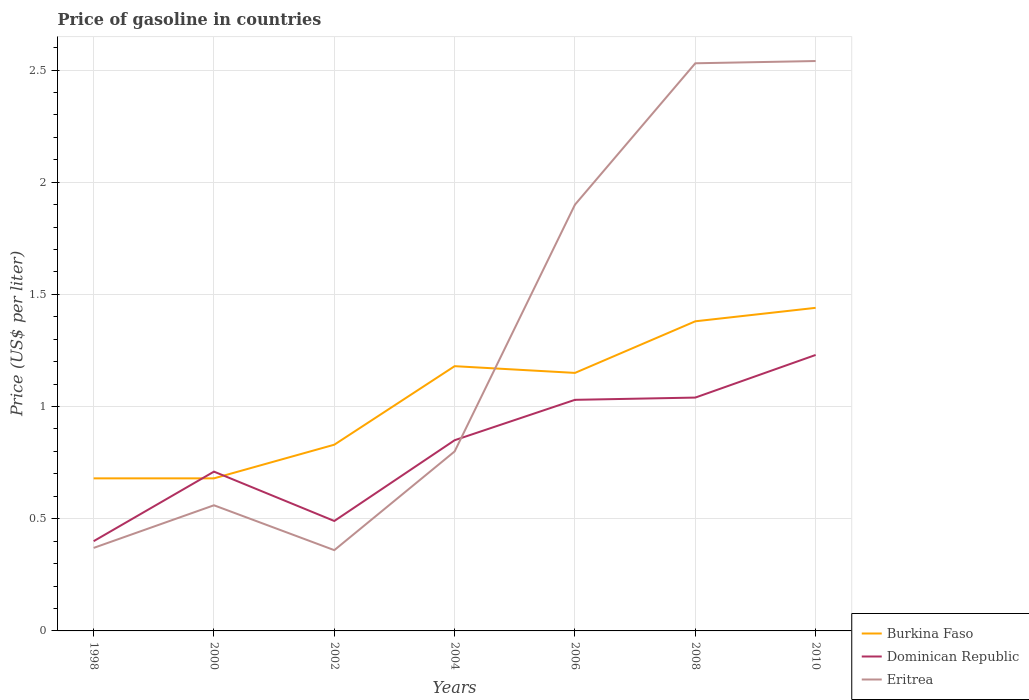How many different coloured lines are there?
Keep it short and to the point. 3. Across all years, what is the maximum price of gasoline in Eritrea?
Provide a short and direct response. 0.36. In which year was the price of gasoline in Burkina Faso maximum?
Offer a terse response. 1998. What is the total price of gasoline in Dominican Republic in the graph?
Keep it short and to the point. -0.32. What is the difference between the highest and the second highest price of gasoline in Eritrea?
Ensure brevity in your answer.  2.18. What is the difference between the highest and the lowest price of gasoline in Burkina Faso?
Give a very brief answer. 4. How many years are there in the graph?
Your answer should be compact. 7. What is the difference between two consecutive major ticks on the Y-axis?
Your response must be concise. 0.5. Are the values on the major ticks of Y-axis written in scientific E-notation?
Give a very brief answer. No. Does the graph contain any zero values?
Keep it short and to the point. No. Where does the legend appear in the graph?
Provide a short and direct response. Bottom right. How are the legend labels stacked?
Your answer should be very brief. Vertical. What is the title of the graph?
Provide a succinct answer. Price of gasoline in countries. Does "South Sudan" appear as one of the legend labels in the graph?
Offer a very short reply. No. What is the label or title of the Y-axis?
Your response must be concise. Price (US$ per liter). What is the Price (US$ per liter) of Burkina Faso in 1998?
Provide a short and direct response. 0.68. What is the Price (US$ per liter) in Dominican Republic in 1998?
Provide a short and direct response. 0.4. What is the Price (US$ per liter) in Eritrea in 1998?
Provide a short and direct response. 0.37. What is the Price (US$ per liter) in Burkina Faso in 2000?
Keep it short and to the point. 0.68. What is the Price (US$ per liter) in Dominican Republic in 2000?
Provide a short and direct response. 0.71. What is the Price (US$ per liter) in Eritrea in 2000?
Offer a very short reply. 0.56. What is the Price (US$ per liter) in Burkina Faso in 2002?
Ensure brevity in your answer.  0.83. What is the Price (US$ per liter) in Dominican Republic in 2002?
Give a very brief answer. 0.49. What is the Price (US$ per liter) of Eritrea in 2002?
Make the answer very short. 0.36. What is the Price (US$ per liter) of Burkina Faso in 2004?
Your response must be concise. 1.18. What is the Price (US$ per liter) of Burkina Faso in 2006?
Offer a terse response. 1.15. What is the Price (US$ per liter) in Dominican Republic in 2006?
Provide a succinct answer. 1.03. What is the Price (US$ per liter) in Burkina Faso in 2008?
Provide a succinct answer. 1.38. What is the Price (US$ per liter) of Dominican Republic in 2008?
Offer a terse response. 1.04. What is the Price (US$ per liter) in Eritrea in 2008?
Provide a succinct answer. 2.53. What is the Price (US$ per liter) in Burkina Faso in 2010?
Provide a succinct answer. 1.44. What is the Price (US$ per liter) in Dominican Republic in 2010?
Keep it short and to the point. 1.23. What is the Price (US$ per liter) in Eritrea in 2010?
Your response must be concise. 2.54. Across all years, what is the maximum Price (US$ per liter) of Burkina Faso?
Provide a succinct answer. 1.44. Across all years, what is the maximum Price (US$ per liter) of Dominican Republic?
Your answer should be very brief. 1.23. Across all years, what is the maximum Price (US$ per liter) in Eritrea?
Provide a short and direct response. 2.54. Across all years, what is the minimum Price (US$ per liter) in Burkina Faso?
Provide a succinct answer. 0.68. Across all years, what is the minimum Price (US$ per liter) in Eritrea?
Make the answer very short. 0.36. What is the total Price (US$ per liter) in Burkina Faso in the graph?
Provide a succinct answer. 7.34. What is the total Price (US$ per liter) of Dominican Republic in the graph?
Offer a very short reply. 5.75. What is the total Price (US$ per liter) of Eritrea in the graph?
Offer a terse response. 9.06. What is the difference between the Price (US$ per liter) of Dominican Republic in 1998 and that in 2000?
Make the answer very short. -0.31. What is the difference between the Price (US$ per liter) of Eritrea in 1998 and that in 2000?
Give a very brief answer. -0.19. What is the difference between the Price (US$ per liter) of Dominican Republic in 1998 and that in 2002?
Offer a terse response. -0.09. What is the difference between the Price (US$ per liter) in Dominican Republic in 1998 and that in 2004?
Make the answer very short. -0.45. What is the difference between the Price (US$ per liter) of Eritrea in 1998 and that in 2004?
Ensure brevity in your answer.  -0.43. What is the difference between the Price (US$ per liter) in Burkina Faso in 1998 and that in 2006?
Your answer should be compact. -0.47. What is the difference between the Price (US$ per liter) of Dominican Republic in 1998 and that in 2006?
Your response must be concise. -0.63. What is the difference between the Price (US$ per liter) in Eritrea in 1998 and that in 2006?
Your answer should be very brief. -1.53. What is the difference between the Price (US$ per liter) in Burkina Faso in 1998 and that in 2008?
Keep it short and to the point. -0.7. What is the difference between the Price (US$ per liter) in Dominican Republic in 1998 and that in 2008?
Keep it short and to the point. -0.64. What is the difference between the Price (US$ per liter) of Eritrea in 1998 and that in 2008?
Offer a very short reply. -2.16. What is the difference between the Price (US$ per liter) of Burkina Faso in 1998 and that in 2010?
Your answer should be compact. -0.76. What is the difference between the Price (US$ per liter) in Dominican Republic in 1998 and that in 2010?
Offer a very short reply. -0.83. What is the difference between the Price (US$ per liter) in Eritrea in 1998 and that in 2010?
Keep it short and to the point. -2.17. What is the difference between the Price (US$ per liter) in Dominican Republic in 2000 and that in 2002?
Your answer should be compact. 0.22. What is the difference between the Price (US$ per liter) in Eritrea in 2000 and that in 2002?
Offer a very short reply. 0.2. What is the difference between the Price (US$ per liter) of Burkina Faso in 2000 and that in 2004?
Your answer should be compact. -0.5. What is the difference between the Price (US$ per liter) of Dominican Republic in 2000 and that in 2004?
Provide a succinct answer. -0.14. What is the difference between the Price (US$ per liter) in Eritrea in 2000 and that in 2004?
Make the answer very short. -0.24. What is the difference between the Price (US$ per liter) of Burkina Faso in 2000 and that in 2006?
Your response must be concise. -0.47. What is the difference between the Price (US$ per liter) of Dominican Republic in 2000 and that in 2006?
Give a very brief answer. -0.32. What is the difference between the Price (US$ per liter) in Eritrea in 2000 and that in 2006?
Ensure brevity in your answer.  -1.34. What is the difference between the Price (US$ per liter) of Burkina Faso in 2000 and that in 2008?
Offer a terse response. -0.7. What is the difference between the Price (US$ per liter) of Dominican Republic in 2000 and that in 2008?
Provide a short and direct response. -0.33. What is the difference between the Price (US$ per liter) of Eritrea in 2000 and that in 2008?
Your answer should be very brief. -1.97. What is the difference between the Price (US$ per liter) of Burkina Faso in 2000 and that in 2010?
Ensure brevity in your answer.  -0.76. What is the difference between the Price (US$ per liter) of Dominican Republic in 2000 and that in 2010?
Make the answer very short. -0.52. What is the difference between the Price (US$ per liter) in Eritrea in 2000 and that in 2010?
Provide a succinct answer. -1.98. What is the difference between the Price (US$ per liter) in Burkina Faso in 2002 and that in 2004?
Give a very brief answer. -0.35. What is the difference between the Price (US$ per liter) in Dominican Republic in 2002 and that in 2004?
Offer a very short reply. -0.36. What is the difference between the Price (US$ per liter) of Eritrea in 2002 and that in 2004?
Your response must be concise. -0.44. What is the difference between the Price (US$ per liter) of Burkina Faso in 2002 and that in 2006?
Give a very brief answer. -0.32. What is the difference between the Price (US$ per liter) in Dominican Republic in 2002 and that in 2006?
Ensure brevity in your answer.  -0.54. What is the difference between the Price (US$ per liter) of Eritrea in 2002 and that in 2006?
Keep it short and to the point. -1.54. What is the difference between the Price (US$ per liter) in Burkina Faso in 2002 and that in 2008?
Ensure brevity in your answer.  -0.55. What is the difference between the Price (US$ per liter) of Dominican Republic in 2002 and that in 2008?
Give a very brief answer. -0.55. What is the difference between the Price (US$ per liter) in Eritrea in 2002 and that in 2008?
Provide a succinct answer. -2.17. What is the difference between the Price (US$ per liter) in Burkina Faso in 2002 and that in 2010?
Keep it short and to the point. -0.61. What is the difference between the Price (US$ per liter) in Dominican Republic in 2002 and that in 2010?
Your answer should be compact. -0.74. What is the difference between the Price (US$ per liter) of Eritrea in 2002 and that in 2010?
Your answer should be very brief. -2.18. What is the difference between the Price (US$ per liter) in Burkina Faso in 2004 and that in 2006?
Provide a succinct answer. 0.03. What is the difference between the Price (US$ per liter) in Dominican Republic in 2004 and that in 2006?
Provide a short and direct response. -0.18. What is the difference between the Price (US$ per liter) in Dominican Republic in 2004 and that in 2008?
Offer a terse response. -0.19. What is the difference between the Price (US$ per liter) of Eritrea in 2004 and that in 2008?
Offer a very short reply. -1.73. What is the difference between the Price (US$ per liter) of Burkina Faso in 2004 and that in 2010?
Make the answer very short. -0.26. What is the difference between the Price (US$ per liter) of Dominican Republic in 2004 and that in 2010?
Provide a short and direct response. -0.38. What is the difference between the Price (US$ per liter) of Eritrea in 2004 and that in 2010?
Offer a terse response. -1.74. What is the difference between the Price (US$ per liter) of Burkina Faso in 2006 and that in 2008?
Your response must be concise. -0.23. What is the difference between the Price (US$ per liter) in Dominican Republic in 2006 and that in 2008?
Your response must be concise. -0.01. What is the difference between the Price (US$ per liter) of Eritrea in 2006 and that in 2008?
Your answer should be compact. -0.63. What is the difference between the Price (US$ per liter) of Burkina Faso in 2006 and that in 2010?
Offer a terse response. -0.29. What is the difference between the Price (US$ per liter) of Eritrea in 2006 and that in 2010?
Ensure brevity in your answer.  -0.64. What is the difference between the Price (US$ per liter) in Burkina Faso in 2008 and that in 2010?
Provide a succinct answer. -0.06. What is the difference between the Price (US$ per liter) in Dominican Republic in 2008 and that in 2010?
Provide a succinct answer. -0.19. What is the difference between the Price (US$ per liter) of Eritrea in 2008 and that in 2010?
Provide a succinct answer. -0.01. What is the difference between the Price (US$ per liter) in Burkina Faso in 1998 and the Price (US$ per liter) in Dominican Republic in 2000?
Your response must be concise. -0.03. What is the difference between the Price (US$ per liter) in Burkina Faso in 1998 and the Price (US$ per liter) in Eritrea in 2000?
Offer a terse response. 0.12. What is the difference between the Price (US$ per liter) of Dominican Republic in 1998 and the Price (US$ per liter) of Eritrea in 2000?
Your answer should be very brief. -0.16. What is the difference between the Price (US$ per liter) of Burkina Faso in 1998 and the Price (US$ per liter) of Dominican Republic in 2002?
Keep it short and to the point. 0.19. What is the difference between the Price (US$ per liter) in Burkina Faso in 1998 and the Price (US$ per liter) in Eritrea in 2002?
Keep it short and to the point. 0.32. What is the difference between the Price (US$ per liter) in Dominican Republic in 1998 and the Price (US$ per liter) in Eritrea in 2002?
Your response must be concise. 0.04. What is the difference between the Price (US$ per liter) of Burkina Faso in 1998 and the Price (US$ per liter) of Dominican Republic in 2004?
Ensure brevity in your answer.  -0.17. What is the difference between the Price (US$ per liter) of Burkina Faso in 1998 and the Price (US$ per liter) of Eritrea in 2004?
Offer a very short reply. -0.12. What is the difference between the Price (US$ per liter) in Dominican Republic in 1998 and the Price (US$ per liter) in Eritrea in 2004?
Your response must be concise. -0.4. What is the difference between the Price (US$ per liter) of Burkina Faso in 1998 and the Price (US$ per liter) of Dominican Republic in 2006?
Provide a short and direct response. -0.35. What is the difference between the Price (US$ per liter) in Burkina Faso in 1998 and the Price (US$ per liter) in Eritrea in 2006?
Make the answer very short. -1.22. What is the difference between the Price (US$ per liter) in Dominican Republic in 1998 and the Price (US$ per liter) in Eritrea in 2006?
Give a very brief answer. -1.5. What is the difference between the Price (US$ per liter) of Burkina Faso in 1998 and the Price (US$ per liter) of Dominican Republic in 2008?
Keep it short and to the point. -0.36. What is the difference between the Price (US$ per liter) of Burkina Faso in 1998 and the Price (US$ per liter) of Eritrea in 2008?
Make the answer very short. -1.85. What is the difference between the Price (US$ per liter) of Dominican Republic in 1998 and the Price (US$ per liter) of Eritrea in 2008?
Provide a short and direct response. -2.13. What is the difference between the Price (US$ per liter) of Burkina Faso in 1998 and the Price (US$ per liter) of Dominican Republic in 2010?
Provide a succinct answer. -0.55. What is the difference between the Price (US$ per liter) in Burkina Faso in 1998 and the Price (US$ per liter) in Eritrea in 2010?
Provide a succinct answer. -1.86. What is the difference between the Price (US$ per liter) of Dominican Republic in 1998 and the Price (US$ per liter) of Eritrea in 2010?
Make the answer very short. -2.14. What is the difference between the Price (US$ per liter) of Burkina Faso in 2000 and the Price (US$ per liter) of Dominican Republic in 2002?
Offer a terse response. 0.19. What is the difference between the Price (US$ per liter) in Burkina Faso in 2000 and the Price (US$ per liter) in Eritrea in 2002?
Keep it short and to the point. 0.32. What is the difference between the Price (US$ per liter) in Burkina Faso in 2000 and the Price (US$ per liter) in Dominican Republic in 2004?
Ensure brevity in your answer.  -0.17. What is the difference between the Price (US$ per liter) in Burkina Faso in 2000 and the Price (US$ per liter) in Eritrea in 2004?
Provide a succinct answer. -0.12. What is the difference between the Price (US$ per liter) of Dominican Republic in 2000 and the Price (US$ per liter) of Eritrea in 2004?
Offer a terse response. -0.09. What is the difference between the Price (US$ per liter) of Burkina Faso in 2000 and the Price (US$ per liter) of Dominican Republic in 2006?
Your answer should be compact. -0.35. What is the difference between the Price (US$ per liter) of Burkina Faso in 2000 and the Price (US$ per liter) of Eritrea in 2006?
Give a very brief answer. -1.22. What is the difference between the Price (US$ per liter) of Dominican Republic in 2000 and the Price (US$ per liter) of Eritrea in 2006?
Offer a very short reply. -1.19. What is the difference between the Price (US$ per liter) in Burkina Faso in 2000 and the Price (US$ per liter) in Dominican Republic in 2008?
Ensure brevity in your answer.  -0.36. What is the difference between the Price (US$ per liter) in Burkina Faso in 2000 and the Price (US$ per liter) in Eritrea in 2008?
Give a very brief answer. -1.85. What is the difference between the Price (US$ per liter) in Dominican Republic in 2000 and the Price (US$ per liter) in Eritrea in 2008?
Give a very brief answer. -1.82. What is the difference between the Price (US$ per liter) of Burkina Faso in 2000 and the Price (US$ per liter) of Dominican Republic in 2010?
Offer a terse response. -0.55. What is the difference between the Price (US$ per liter) in Burkina Faso in 2000 and the Price (US$ per liter) in Eritrea in 2010?
Give a very brief answer. -1.86. What is the difference between the Price (US$ per liter) in Dominican Republic in 2000 and the Price (US$ per liter) in Eritrea in 2010?
Your response must be concise. -1.83. What is the difference between the Price (US$ per liter) in Burkina Faso in 2002 and the Price (US$ per liter) in Dominican Republic in 2004?
Offer a very short reply. -0.02. What is the difference between the Price (US$ per liter) in Burkina Faso in 2002 and the Price (US$ per liter) in Eritrea in 2004?
Provide a succinct answer. 0.03. What is the difference between the Price (US$ per liter) in Dominican Republic in 2002 and the Price (US$ per liter) in Eritrea in 2004?
Offer a terse response. -0.31. What is the difference between the Price (US$ per liter) in Burkina Faso in 2002 and the Price (US$ per liter) in Dominican Republic in 2006?
Give a very brief answer. -0.2. What is the difference between the Price (US$ per liter) of Burkina Faso in 2002 and the Price (US$ per liter) of Eritrea in 2006?
Ensure brevity in your answer.  -1.07. What is the difference between the Price (US$ per liter) of Dominican Republic in 2002 and the Price (US$ per liter) of Eritrea in 2006?
Offer a terse response. -1.41. What is the difference between the Price (US$ per liter) in Burkina Faso in 2002 and the Price (US$ per liter) in Dominican Republic in 2008?
Give a very brief answer. -0.21. What is the difference between the Price (US$ per liter) of Burkina Faso in 2002 and the Price (US$ per liter) of Eritrea in 2008?
Offer a very short reply. -1.7. What is the difference between the Price (US$ per liter) of Dominican Republic in 2002 and the Price (US$ per liter) of Eritrea in 2008?
Your answer should be very brief. -2.04. What is the difference between the Price (US$ per liter) in Burkina Faso in 2002 and the Price (US$ per liter) in Eritrea in 2010?
Make the answer very short. -1.71. What is the difference between the Price (US$ per liter) of Dominican Republic in 2002 and the Price (US$ per liter) of Eritrea in 2010?
Ensure brevity in your answer.  -2.05. What is the difference between the Price (US$ per liter) of Burkina Faso in 2004 and the Price (US$ per liter) of Eritrea in 2006?
Your answer should be very brief. -0.72. What is the difference between the Price (US$ per liter) of Dominican Republic in 2004 and the Price (US$ per liter) of Eritrea in 2006?
Offer a terse response. -1.05. What is the difference between the Price (US$ per liter) of Burkina Faso in 2004 and the Price (US$ per liter) of Dominican Republic in 2008?
Provide a succinct answer. 0.14. What is the difference between the Price (US$ per liter) in Burkina Faso in 2004 and the Price (US$ per liter) in Eritrea in 2008?
Your answer should be compact. -1.35. What is the difference between the Price (US$ per liter) of Dominican Republic in 2004 and the Price (US$ per liter) of Eritrea in 2008?
Give a very brief answer. -1.68. What is the difference between the Price (US$ per liter) of Burkina Faso in 2004 and the Price (US$ per liter) of Eritrea in 2010?
Provide a short and direct response. -1.36. What is the difference between the Price (US$ per liter) in Dominican Republic in 2004 and the Price (US$ per liter) in Eritrea in 2010?
Offer a terse response. -1.69. What is the difference between the Price (US$ per liter) of Burkina Faso in 2006 and the Price (US$ per liter) of Dominican Republic in 2008?
Make the answer very short. 0.11. What is the difference between the Price (US$ per liter) of Burkina Faso in 2006 and the Price (US$ per liter) of Eritrea in 2008?
Offer a very short reply. -1.38. What is the difference between the Price (US$ per liter) of Dominican Republic in 2006 and the Price (US$ per liter) of Eritrea in 2008?
Offer a terse response. -1.5. What is the difference between the Price (US$ per liter) in Burkina Faso in 2006 and the Price (US$ per liter) in Dominican Republic in 2010?
Your response must be concise. -0.08. What is the difference between the Price (US$ per liter) of Burkina Faso in 2006 and the Price (US$ per liter) of Eritrea in 2010?
Provide a short and direct response. -1.39. What is the difference between the Price (US$ per liter) in Dominican Republic in 2006 and the Price (US$ per liter) in Eritrea in 2010?
Ensure brevity in your answer.  -1.51. What is the difference between the Price (US$ per liter) of Burkina Faso in 2008 and the Price (US$ per liter) of Eritrea in 2010?
Provide a succinct answer. -1.16. What is the difference between the Price (US$ per liter) of Dominican Republic in 2008 and the Price (US$ per liter) of Eritrea in 2010?
Offer a very short reply. -1.5. What is the average Price (US$ per liter) of Burkina Faso per year?
Ensure brevity in your answer.  1.05. What is the average Price (US$ per liter) of Dominican Republic per year?
Make the answer very short. 0.82. What is the average Price (US$ per liter) in Eritrea per year?
Provide a succinct answer. 1.29. In the year 1998, what is the difference between the Price (US$ per liter) in Burkina Faso and Price (US$ per liter) in Dominican Republic?
Your answer should be compact. 0.28. In the year 1998, what is the difference between the Price (US$ per liter) of Burkina Faso and Price (US$ per liter) of Eritrea?
Provide a short and direct response. 0.31. In the year 2000, what is the difference between the Price (US$ per liter) in Burkina Faso and Price (US$ per liter) in Dominican Republic?
Offer a terse response. -0.03. In the year 2000, what is the difference between the Price (US$ per liter) of Burkina Faso and Price (US$ per liter) of Eritrea?
Your answer should be compact. 0.12. In the year 2002, what is the difference between the Price (US$ per liter) of Burkina Faso and Price (US$ per liter) of Dominican Republic?
Ensure brevity in your answer.  0.34. In the year 2002, what is the difference between the Price (US$ per liter) of Burkina Faso and Price (US$ per liter) of Eritrea?
Your answer should be compact. 0.47. In the year 2002, what is the difference between the Price (US$ per liter) in Dominican Republic and Price (US$ per liter) in Eritrea?
Your answer should be very brief. 0.13. In the year 2004, what is the difference between the Price (US$ per liter) in Burkina Faso and Price (US$ per liter) in Dominican Republic?
Provide a short and direct response. 0.33. In the year 2004, what is the difference between the Price (US$ per liter) of Burkina Faso and Price (US$ per liter) of Eritrea?
Give a very brief answer. 0.38. In the year 2004, what is the difference between the Price (US$ per liter) in Dominican Republic and Price (US$ per liter) in Eritrea?
Your answer should be very brief. 0.05. In the year 2006, what is the difference between the Price (US$ per liter) of Burkina Faso and Price (US$ per liter) of Dominican Republic?
Offer a very short reply. 0.12. In the year 2006, what is the difference between the Price (US$ per liter) in Burkina Faso and Price (US$ per liter) in Eritrea?
Your answer should be compact. -0.75. In the year 2006, what is the difference between the Price (US$ per liter) of Dominican Republic and Price (US$ per liter) of Eritrea?
Offer a very short reply. -0.87. In the year 2008, what is the difference between the Price (US$ per liter) in Burkina Faso and Price (US$ per liter) in Dominican Republic?
Keep it short and to the point. 0.34. In the year 2008, what is the difference between the Price (US$ per liter) in Burkina Faso and Price (US$ per liter) in Eritrea?
Ensure brevity in your answer.  -1.15. In the year 2008, what is the difference between the Price (US$ per liter) of Dominican Republic and Price (US$ per liter) of Eritrea?
Give a very brief answer. -1.49. In the year 2010, what is the difference between the Price (US$ per liter) of Burkina Faso and Price (US$ per liter) of Dominican Republic?
Your answer should be very brief. 0.21. In the year 2010, what is the difference between the Price (US$ per liter) of Dominican Republic and Price (US$ per liter) of Eritrea?
Your answer should be compact. -1.31. What is the ratio of the Price (US$ per liter) of Dominican Republic in 1998 to that in 2000?
Your response must be concise. 0.56. What is the ratio of the Price (US$ per liter) of Eritrea in 1998 to that in 2000?
Keep it short and to the point. 0.66. What is the ratio of the Price (US$ per liter) in Burkina Faso in 1998 to that in 2002?
Offer a terse response. 0.82. What is the ratio of the Price (US$ per liter) in Dominican Republic in 1998 to that in 2002?
Make the answer very short. 0.82. What is the ratio of the Price (US$ per liter) of Eritrea in 1998 to that in 2002?
Offer a very short reply. 1.03. What is the ratio of the Price (US$ per liter) of Burkina Faso in 1998 to that in 2004?
Provide a succinct answer. 0.58. What is the ratio of the Price (US$ per liter) in Dominican Republic in 1998 to that in 2004?
Make the answer very short. 0.47. What is the ratio of the Price (US$ per liter) of Eritrea in 1998 to that in 2004?
Offer a terse response. 0.46. What is the ratio of the Price (US$ per liter) of Burkina Faso in 1998 to that in 2006?
Keep it short and to the point. 0.59. What is the ratio of the Price (US$ per liter) in Dominican Republic in 1998 to that in 2006?
Provide a short and direct response. 0.39. What is the ratio of the Price (US$ per liter) of Eritrea in 1998 to that in 2006?
Offer a terse response. 0.19. What is the ratio of the Price (US$ per liter) in Burkina Faso in 1998 to that in 2008?
Offer a terse response. 0.49. What is the ratio of the Price (US$ per liter) in Dominican Republic in 1998 to that in 2008?
Your response must be concise. 0.38. What is the ratio of the Price (US$ per liter) in Eritrea in 1998 to that in 2008?
Keep it short and to the point. 0.15. What is the ratio of the Price (US$ per liter) of Burkina Faso in 1998 to that in 2010?
Your answer should be very brief. 0.47. What is the ratio of the Price (US$ per liter) of Dominican Republic in 1998 to that in 2010?
Your answer should be very brief. 0.33. What is the ratio of the Price (US$ per liter) of Eritrea in 1998 to that in 2010?
Give a very brief answer. 0.15. What is the ratio of the Price (US$ per liter) in Burkina Faso in 2000 to that in 2002?
Your response must be concise. 0.82. What is the ratio of the Price (US$ per liter) in Dominican Republic in 2000 to that in 2002?
Offer a terse response. 1.45. What is the ratio of the Price (US$ per liter) of Eritrea in 2000 to that in 2002?
Keep it short and to the point. 1.56. What is the ratio of the Price (US$ per liter) of Burkina Faso in 2000 to that in 2004?
Provide a short and direct response. 0.58. What is the ratio of the Price (US$ per liter) in Dominican Republic in 2000 to that in 2004?
Give a very brief answer. 0.84. What is the ratio of the Price (US$ per liter) in Eritrea in 2000 to that in 2004?
Give a very brief answer. 0.7. What is the ratio of the Price (US$ per liter) in Burkina Faso in 2000 to that in 2006?
Give a very brief answer. 0.59. What is the ratio of the Price (US$ per liter) in Dominican Republic in 2000 to that in 2006?
Offer a very short reply. 0.69. What is the ratio of the Price (US$ per liter) in Eritrea in 2000 to that in 2006?
Offer a very short reply. 0.29. What is the ratio of the Price (US$ per liter) in Burkina Faso in 2000 to that in 2008?
Your response must be concise. 0.49. What is the ratio of the Price (US$ per liter) in Dominican Republic in 2000 to that in 2008?
Ensure brevity in your answer.  0.68. What is the ratio of the Price (US$ per liter) of Eritrea in 2000 to that in 2008?
Your response must be concise. 0.22. What is the ratio of the Price (US$ per liter) in Burkina Faso in 2000 to that in 2010?
Provide a short and direct response. 0.47. What is the ratio of the Price (US$ per liter) in Dominican Republic in 2000 to that in 2010?
Offer a very short reply. 0.58. What is the ratio of the Price (US$ per liter) in Eritrea in 2000 to that in 2010?
Your answer should be compact. 0.22. What is the ratio of the Price (US$ per liter) in Burkina Faso in 2002 to that in 2004?
Keep it short and to the point. 0.7. What is the ratio of the Price (US$ per liter) of Dominican Republic in 2002 to that in 2004?
Offer a very short reply. 0.58. What is the ratio of the Price (US$ per liter) in Eritrea in 2002 to that in 2004?
Your response must be concise. 0.45. What is the ratio of the Price (US$ per liter) of Burkina Faso in 2002 to that in 2006?
Your answer should be compact. 0.72. What is the ratio of the Price (US$ per liter) of Dominican Republic in 2002 to that in 2006?
Offer a terse response. 0.48. What is the ratio of the Price (US$ per liter) in Eritrea in 2002 to that in 2006?
Offer a terse response. 0.19. What is the ratio of the Price (US$ per liter) of Burkina Faso in 2002 to that in 2008?
Give a very brief answer. 0.6. What is the ratio of the Price (US$ per liter) in Dominican Republic in 2002 to that in 2008?
Your response must be concise. 0.47. What is the ratio of the Price (US$ per liter) of Eritrea in 2002 to that in 2008?
Give a very brief answer. 0.14. What is the ratio of the Price (US$ per liter) of Burkina Faso in 2002 to that in 2010?
Offer a very short reply. 0.58. What is the ratio of the Price (US$ per liter) in Dominican Republic in 2002 to that in 2010?
Your response must be concise. 0.4. What is the ratio of the Price (US$ per liter) in Eritrea in 2002 to that in 2010?
Provide a succinct answer. 0.14. What is the ratio of the Price (US$ per liter) in Burkina Faso in 2004 to that in 2006?
Offer a very short reply. 1.03. What is the ratio of the Price (US$ per liter) of Dominican Republic in 2004 to that in 2006?
Your answer should be compact. 0.83. What is the ratio of the Price (US$ per liter) in Eritrea in 2004 to that in 2006?
Give a very brief answer. 0.42. What is the ratio of the Price (US$ per liter) in Burkina Faso in 2004 to that in 2008?
Ensure brevity in your answer.  0.86. What is the ratio of the Price (US$ per liter) in Dominican Republic in 2004 to that in 2008?
Make the answer very short. 0.82. What is the ratio of the Price (US$ per liter) in Eritrea in 2004 to that in 2008?
Provide a succinct answer. 0.32. What is the ratio of the Price (US$ per liter) of Burkina Faso in 2004 to that in 2010?
Give a very brief answer. 0.82. What is the ratio of the Price (US$ per liter) in Dominican Republic in 2004 to that in 2010?
Keep it short and to the point. 0.69. What is the ratio of the Price (US$ per liter) of Eritrea in 2004 to that in 2010?
Keep it short and to the point. 0.32. What is the ratio of the Price (US$ per liter) in Dominican Republic in 2006 to that in 2008?
Offer a very short reply. 0.99. What is the ratio of the Price (US$ per liter) in Eritrea in 2006 to that in 2008?
Give a very brief answer. 0.75. What is the ratio of the Price (US$ per liter) in Burkina Faso in 2006 to that in 2010?
Offer a terse response. 0.8. What is the ratio of the Price (US$ per liter) in Dominican Republic in 2006 to that in 2010?
Give a very brief answer. 0.84. What is the ratio of the Price (US$ per liter) of Eritrea in 2006 to that in 2010?
Keep it short and to the point. 0.75. What is the ratio of the Price (US$ per liter) of Dominican Republic in 2008 to that in 2010?
Provide a short and direct response. 0.85. What is the difference between the highest and the second highest Price (US$ per liter) of Burkina Faso?
Provide a short and direct response. 0.06. What is the difference between the highest and the second highest Price (US$ per liter) of Dominican Republic?
Ensure brevity in your answer.  0.19. What is the difference between the highest and the lowest Price (US$ per liter) of Burkina Faso?
Offer a very short reply. 0.76. What is the difference between the highest and the lowest Price (US$ per liter) of Dominican Republic?
Give a very brief answer. 0.83. What is the difference between the highest and the lowest Price (US$ per liter) in Eritrea?
Offer a very short reply. 2.18. 